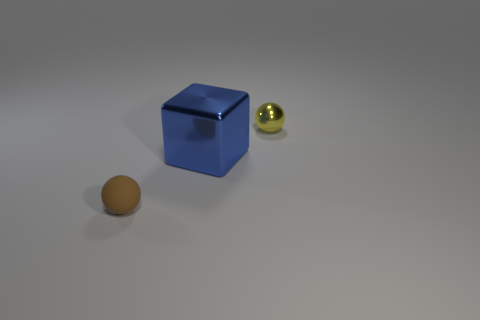Add 3 tiny objects. How many objects exist? 6 Subtract all spheres. How many objects are left? 1 Subtract 0 purple cylinders. How many objects are left? 3 Subtract all tiny purple balls. Subtract all small spheres. How many objects are left? 1 Add 1 blocks. How many blocks are left? 2 Add 2 small brown balls. How many small brown balls exist? 3 